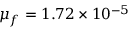Convert formula to latex. <formula><loc_0><loc_0><loc_500><loc_500>\mu _ { f } = 1 . 7 2 \times 1 0 ^ { - 5 }</formula> 